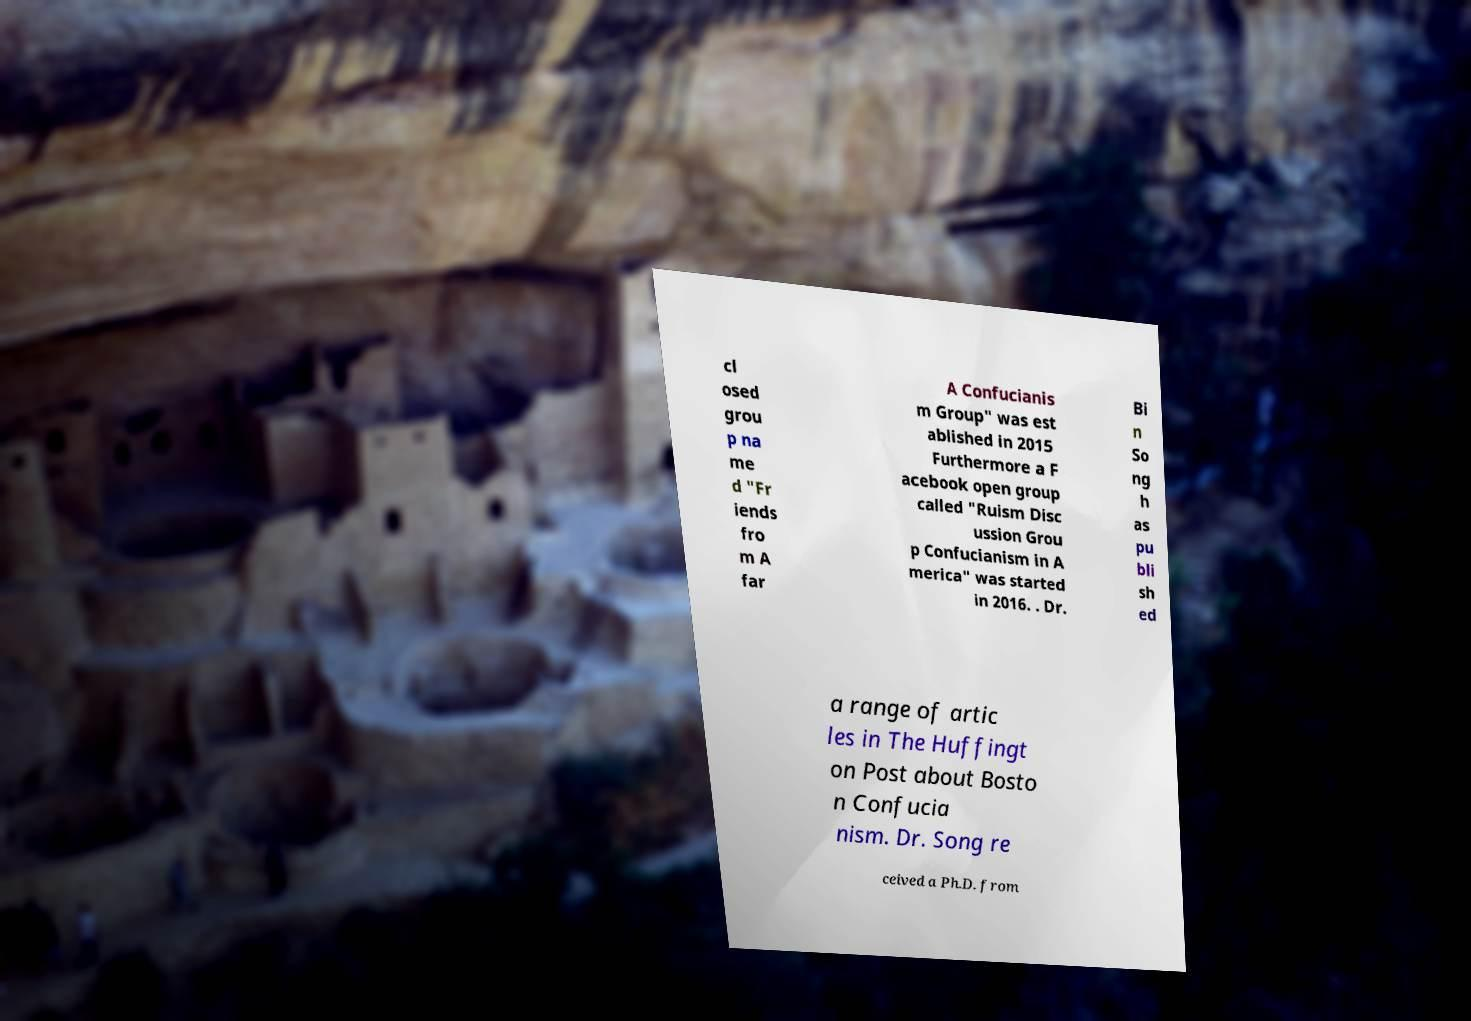I need the written content from this picture converted into text. Can you do that? cl osed grou p na me d "Fr iends fro m A far A Confucianis m Group" was est ablished in 2015 Furthermore a F acebook open group called "Ruism Disc ussion Grou p Confucianism in A merica" was started in 2016. . Dr. Bi n So ng h as pu bli sh ed a range of artic les in The Huffingt on Post about Bosto n Confucia nism. Dr. Song re ceived a Ph.D. from 